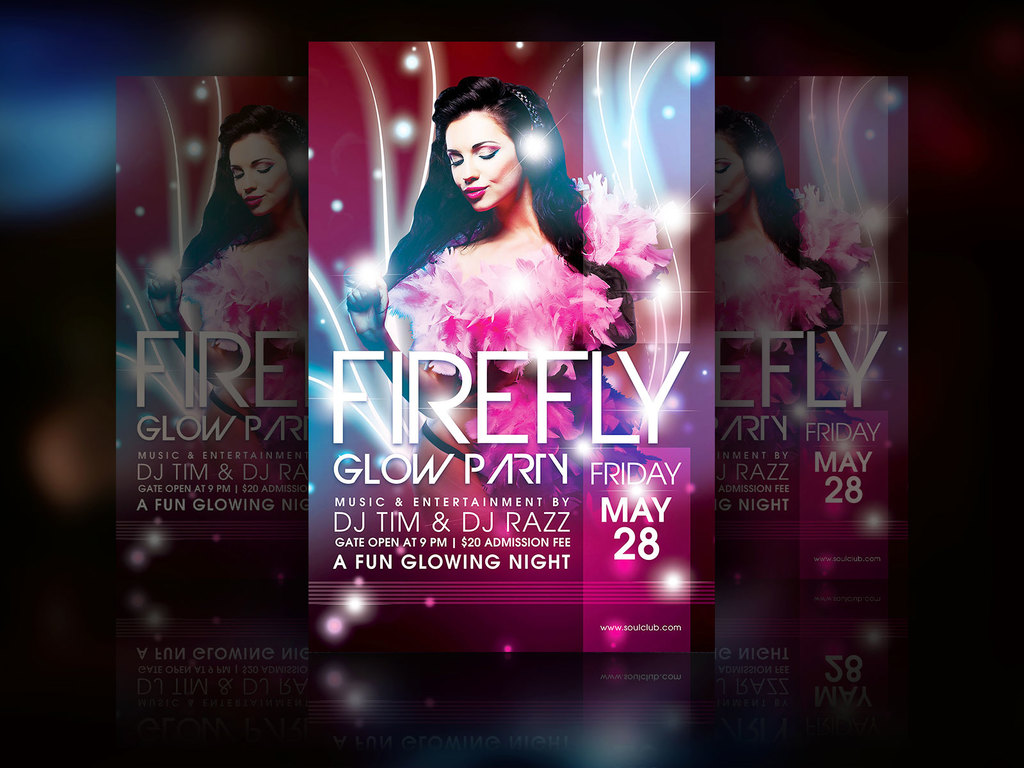Can you describe the visual design and aesthetics used in this poster? The poster utilizes a high contrast, neon color palette predominantly featuring pink, purple, and blue shades. These colors evoke a vibe consistent with nightlife and party events. The design includes glowing elements which mirror the 'glow' theme of the event, while the layered images of the female model add dynamism and a sense of movement. The text is modern and stylish, enhancing the overall energetic feel. How does the choice of colors and lighting affect the mood of the poster? The choice of vibrant neon colors like pink and purple, combined with glowing white and blue accents, creates a lively and energetic mood, mimicking the electrifying atmosphere of a nightlife event. The lighting emphasizes the 'glow' aspect of the party, suggesting excitement and a vibrant, dynamic scene that attracts a youthful, energetic audience. 